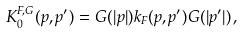<formula> <loc_0><loc_0><loc_500><loc_500>K ^ { F , G } _ { 0 } ( p , p ^ { \prime } ) = G ( | p | ) k _ { F } ( p , p ^ { \prime } ) G ( | p ^ { \prime } | ) \, ,</formula> 